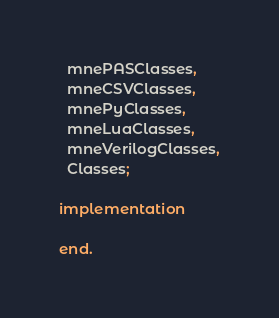<code> <loc_0><loc_0><loc_500><loc_500><_Pascal_>  mnePASClasses,
  mneCSVClasses,
  mnePyClasses,
  mneLuaClasses,
  mneVerilogClasses,
  Classes;

implementation

end.
</code> 